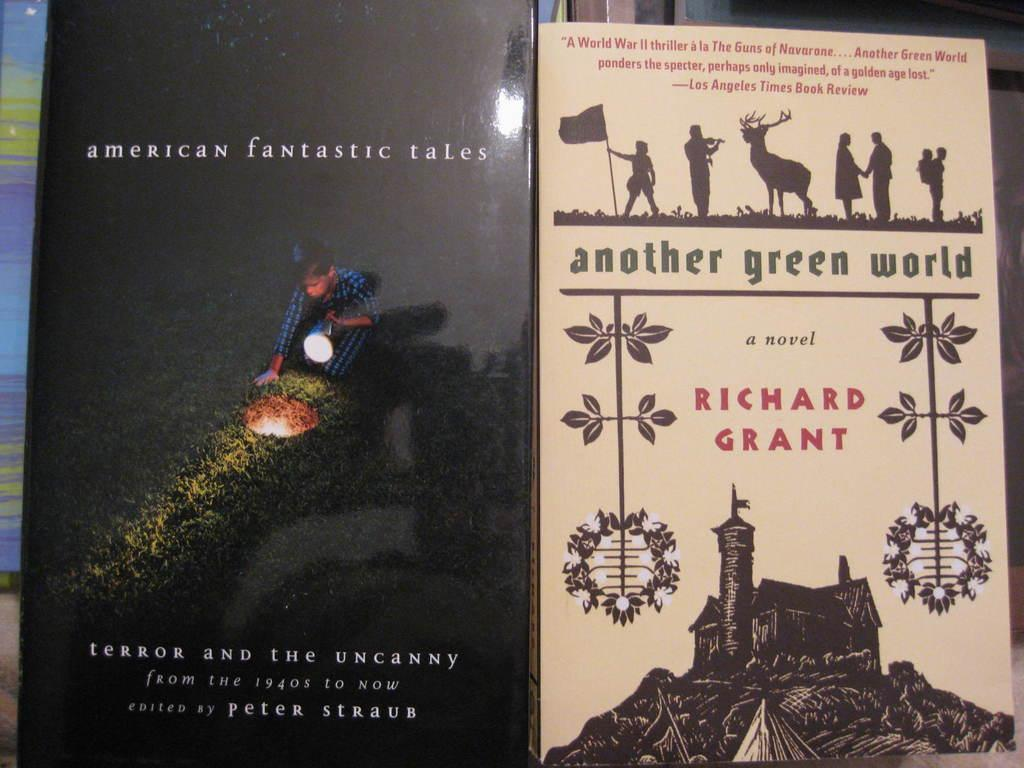<image>
Give a short and clear explanation of the subsequent image. Another Green World, by Richard Grant, shows a house with a tower on the cover. 